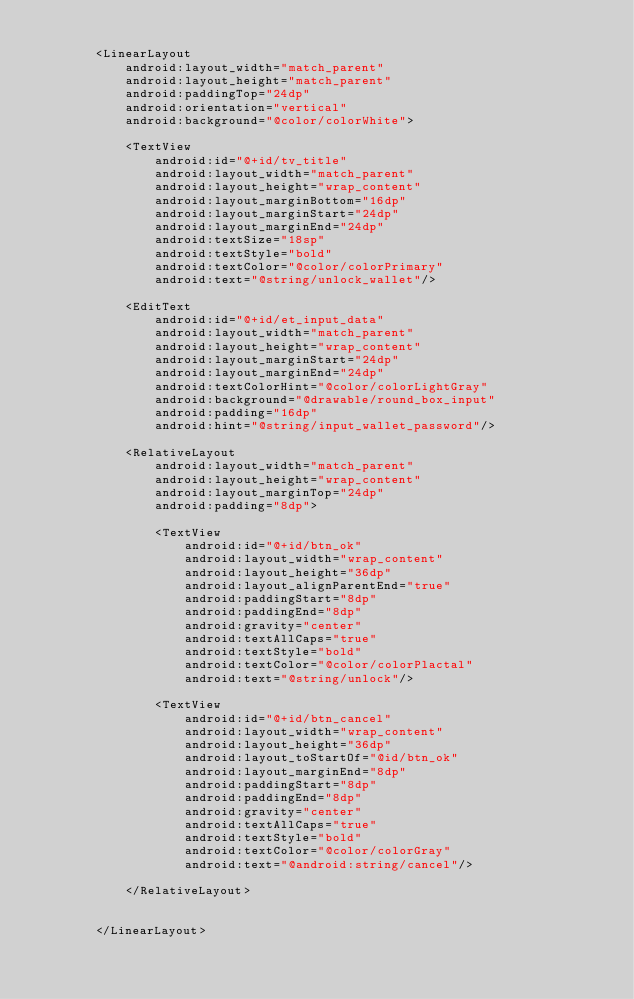<code> <loc_0><loc_0><loc_500><loc_500><_XML_>
        <LinearLayout
            android:layout_width="match_parent"
            android:layout_height="match_parent"
            android:paddingTop="24dp"
            android:orientation="vertical"
            android:background="@color/colorWhite">

            <TextView
                android:id="@+id/tv_title"
                android:layout_width="match_parent"
                android:layout_height="wrap_content"
                android:layout_marginBottom="16dp"
                android:layout_marginStart="24dp"
                android:layout_marginEnd="24dp"
                android:textSize="18sp"
                android:textStyle="bold"
                android:textColor="@color/colorPrimary"
                android:text="@string/unlock_wallet"/>

            <EditText
                android:id="@+id/et_input_data"
                android:layout_width="match_parent"
                android:layout_height="wrap_content"
                android:layout_marginStart="24dp"
                android:layout_marginEnd="24dp"
                android:textColorHint="@color/colorLightGray"
                android:background="@drawable/round_box_input"
                android:padding="16dp"
                android:hint="@string/input_wallet_password"/>

            <RelativeLayout
                android:layout_width="match_parent"
                android:layout_height="wrap_content"
                android:layout_marginTop="24dp"
                android:padding="8dp">

                <TextView
                    android:id="@+id/btn_ok"
                    android:layout_width="wrap_content"
                    android:layout_height="36dp"
                    android:layout_alignParentEnd="true"
                    android:paddingStart="8dp"
                    android:paddingEnd="8dp"
                    android:gravity="center"
                    android:textAllCaps="true"
                    android:textStyle="bold"
                    android:textColor="@color/colorPlactal"
                    android:text="@string/unlock"/>

                <TextView
                    android:id="@+id/btn_cancel"
                    android:layout_width="wrap_content"
                    android:layout_height="36dp"
                    android:layout_toStartOf="@id/btn_ok"
                    android:layout_marginEnd="8dp"
                    android:paddingStart="8dp"
                    android:paddingEnd="8dp"
                    android:gravity="center"
                    android:textAllCaps="true"
                    android:textStyle="bold"
                    android:textColor="@color/colorGray"
                    android:text="@android:string/cancel"/>

            </RelativeLayout>


        </LinearLayout></code> 